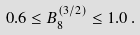Convert formula to latex. <formula><loc_0><loc_0><loc_500><loc_500>0 . 6 \leq B _ { 8 } ^ { ( 3 / 2 ) } \leq 1 . 0 \, .</formula> 